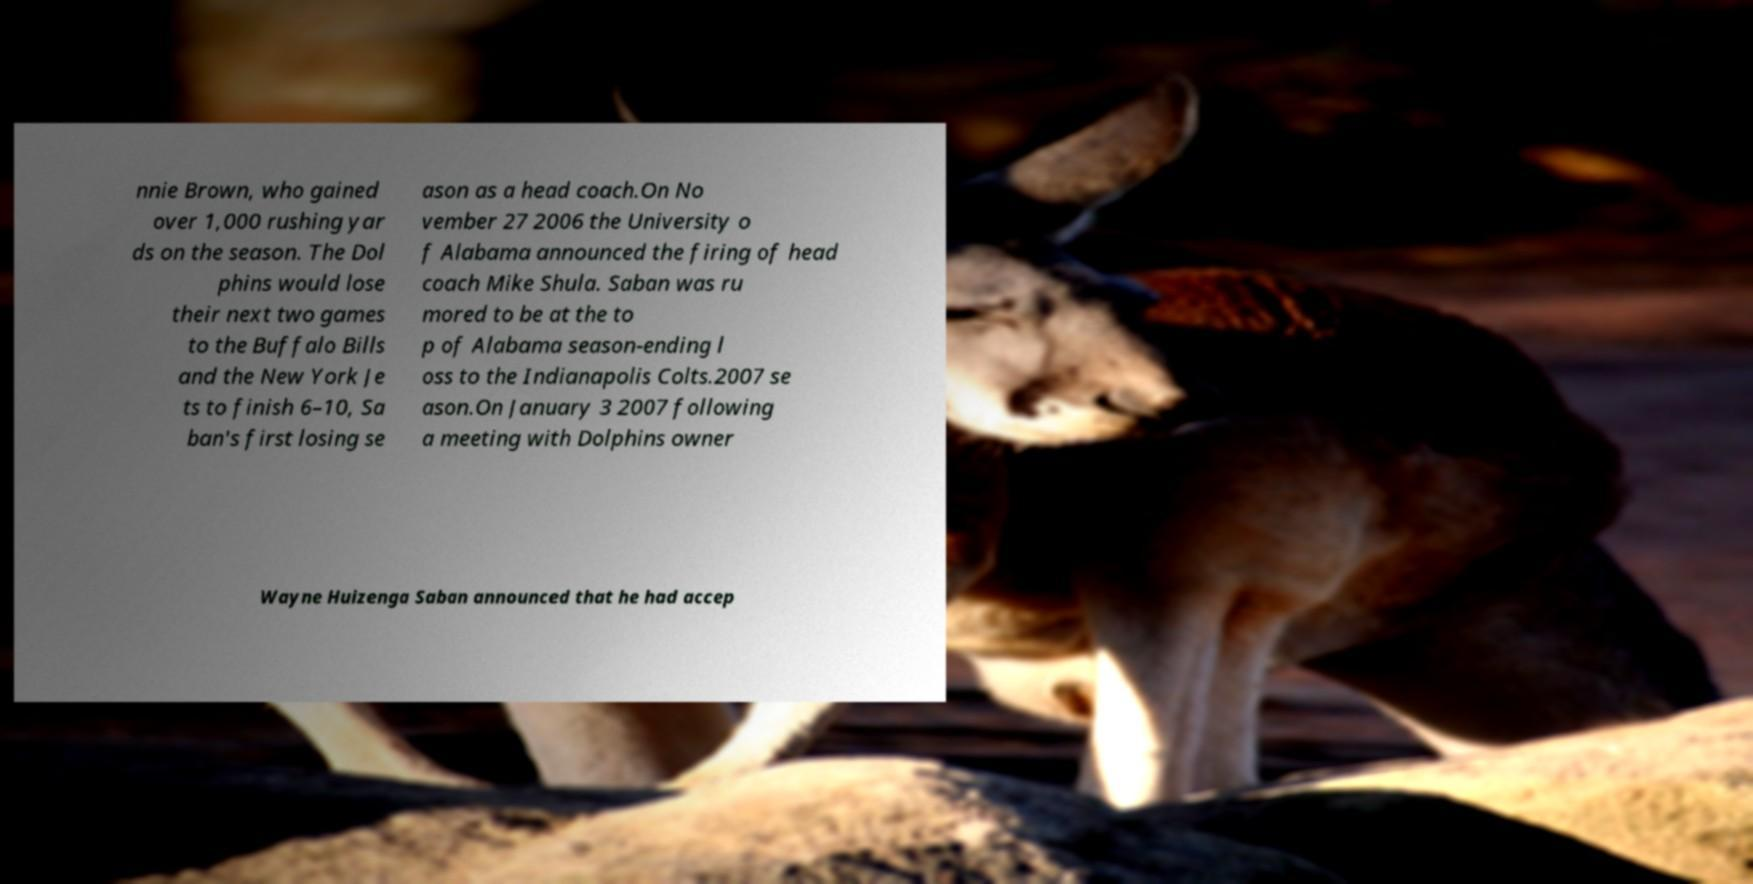Please read and relay the text visible in this image. What does it say? nnie Brown, who gained over 1,000 rushing yar ds on the season. The Dol phins would lose their next two games to the Buffalo Bills and the New York Je ts to finish 6–10, Sa ban's first losing se ason as a head coach.On No vember 27 2006 the University o f Alabama announced the firing of head coach Mike Shula. Saban was ru mored to be at the to p of Alabama season-ending l oss to the Indianapolis Colts.2007 se ason.On January 3 2007 following a meeting with Dolphins owner Wayne Huizenga Saban announced that he had accep 